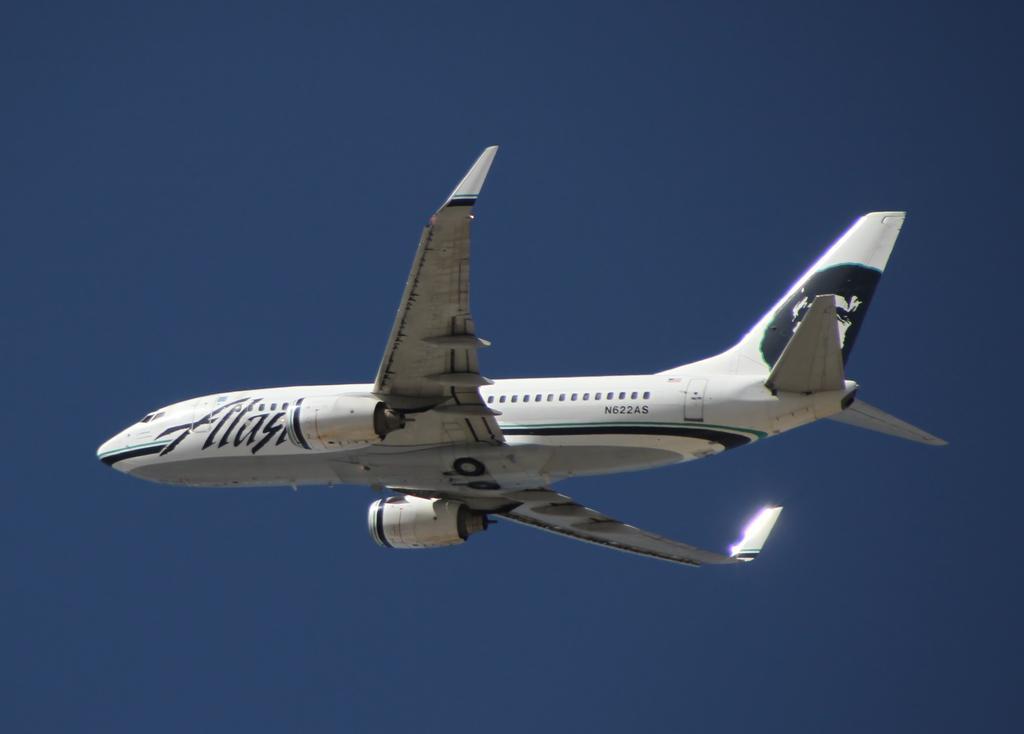How would you summarize this image in a sentence or two? A white aeroplane is flying in the sky towards the left. 